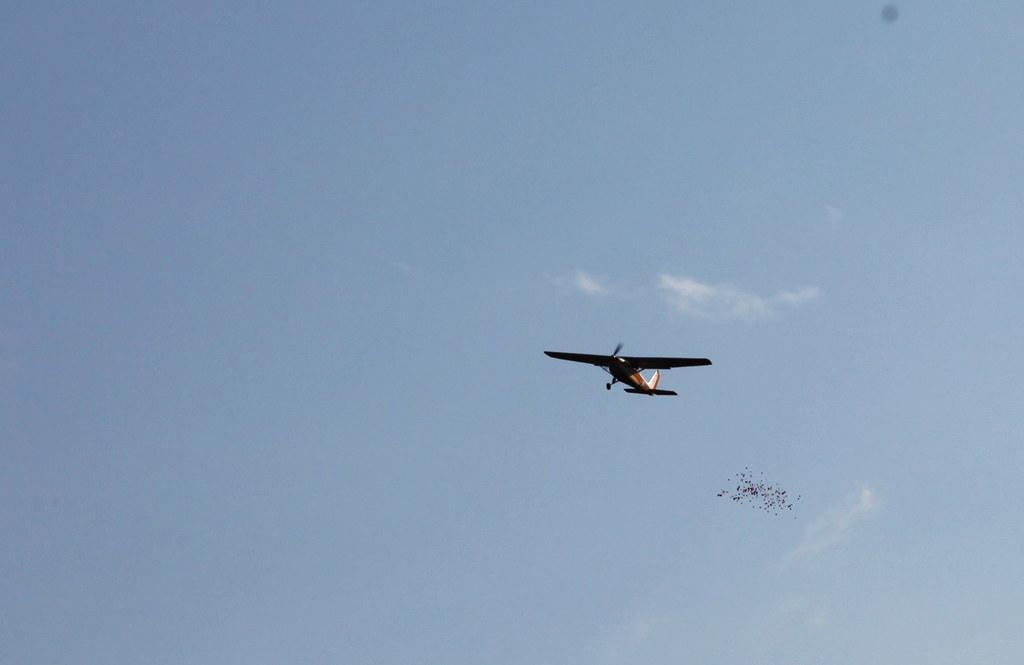Can you describe this image briefly? This image is taken outdoors. In the background there is a sky with clouds. In the middle of the image an airplane is flying in the sky and a few birds are flying in the sky. 